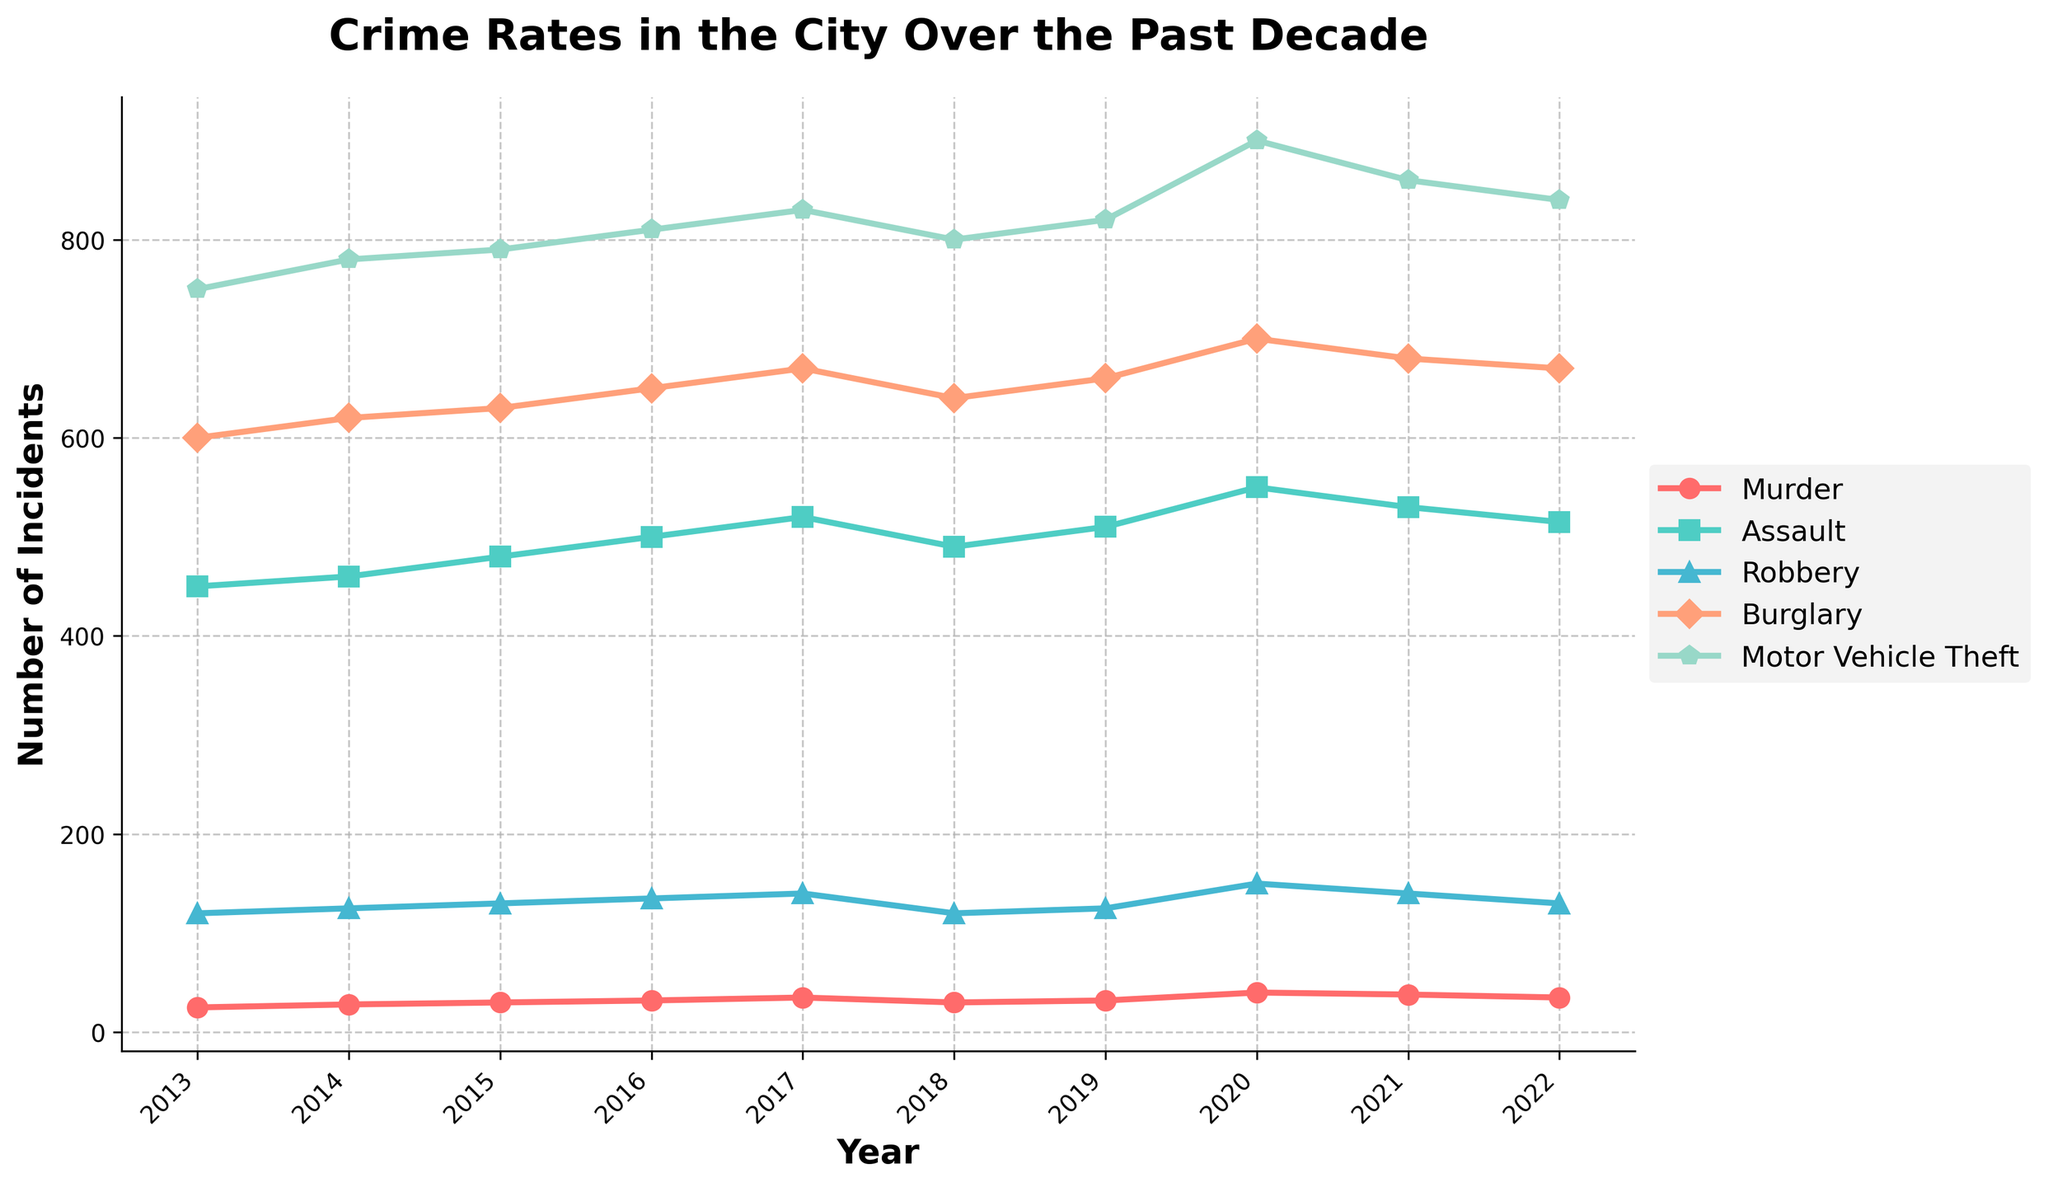Which year had the highest number of murders? The time series plot indicates the number of murders each year. By observing, 2020 had the highest number with 40 incidents
Answer: 2020 How did the number of assaults change from 2013 to 2022? To determine this, compare the counts of assaults in 2013 and 2022. In 2013, there were 450 assaults and in 2022, there were 515. The number increased by 65
Answer: Increased by 65 Which type of crime saw the most significant increase over the decade? To find the crime type with the most significant increase, compare the differences between 2013 and 2022 for all crime types. The largest difference is seen in motor vehicle theft, which increased from 750 to 840
Answer: Motor Vehicle Theft On which year did burglaries peak? The peak for burglaries is the maximum value in the burglary time series. By examining the plot, 2020 had the highest number of burglaries at 700
Answer: 2020 What is the overall trend in murders from 2013 to 2022? Observing the plot, murders increased from 25 in 2013 to a peak of 40 in 2020, then decreased to 35 by 2022. This suggests an increasing trend with a recent decline
Answer: Increasing, then declining In which year did robbery incidences drop, after showing a consistent rise? Robbery incidences increased consistently until 2017 when it was 140 cases. Then, it dropped to 120 in 2018
Answer: 2018 Calculate the average annual increase in motor vehicle thefts from 2013 to 2022. First, find the difference from 2013 to 2022, which is 840 - 750 = 90. There are 9 intervals between the years, so the average annual increase is 90/9 = 10
Answer: 10 Which crime type shows the most fluctuation over the decade? To identify the most fluctuation, observe the variability in the plot for each crime type. Assaults show relatively consistent increases, whereas murder fluctuates notably
Answer: Murder Compare the number of burglaries in 2018 and 2019. Which year was higher? By comparing the values, burglaries in 2018 were 640, while in 2019, they were 660, indicating an increase
Answer: 2019 What were the robbery statistics in years marked by significant crime fluctuations, like 2020 and 2021? In the plot, robbery counts in 2020 reached 150 and slightly reduced to 140 by 2021. This reflects the period of significant change
Answer: 150 in 2020, 140 in 2021 